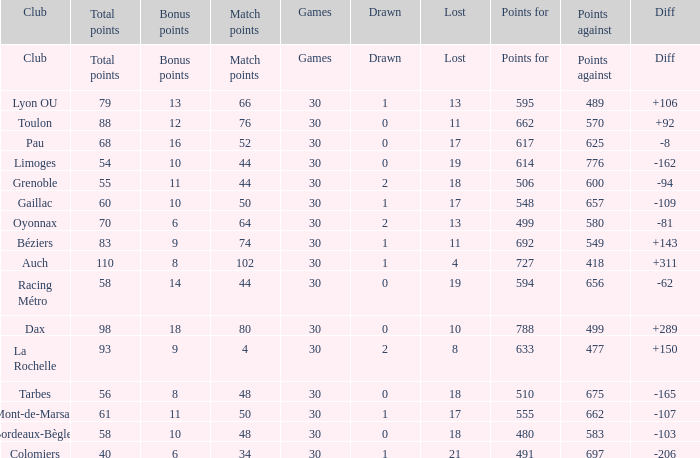What is the value of match points when the points for is 570? 76.0. 